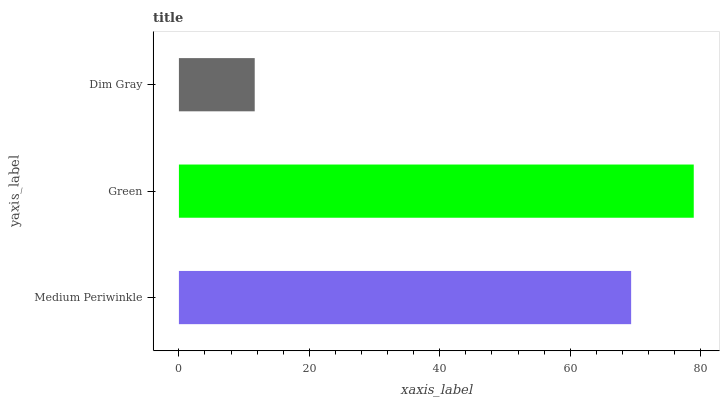Is Dim Gray the minimum?
Answer yes or no. Yes. Is Green the maximum?
Answer yes or no. Yes. Is Green the minimum?
Answer yes or no. No. Is Dim Gray the maximum?
Answer yes or no. No. Is Green greater than Dim Gray?
Answer yes or no. Yes. Is Dim Gray less than Green?
Answer yes or no. Yes. Is Dim Gray greater than Green?
Answer yes or no. No. Is Green less than Dim Gray?
Answer yes or no. No. Is Medium Periwinkle the high median?
Answer yes or no. Yes. Is Medium Periwinkle the low median?
Answer yes or no. Yes. Is Dim Gray the high median?
Answer yes or no. No. Is Dim Gray the low median?
Answer yes or no. No. 